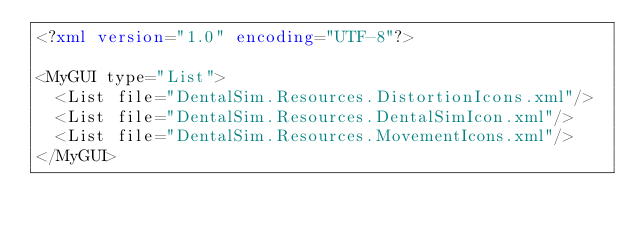<code> <loc_0><loc_0><loc_500><loc_500><_XML_><?xml version="1.0" encoding="UTF-8"?>

<MyGUI type="List">
  <List file="DentalSim.Resources.DistortionIcons.xml"/>
  <List file="DentalSim.Resources.DentalSimIcon.xml"/>
  <List file="DentalSim.Resources.MovementIcons.xml"/>
</MyGUI></code> 